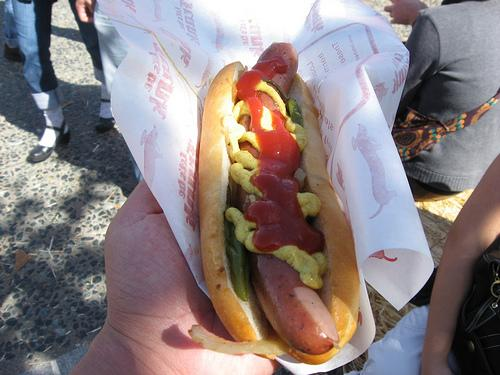Which ingredient contains the highest amount of sodium? hot dog 